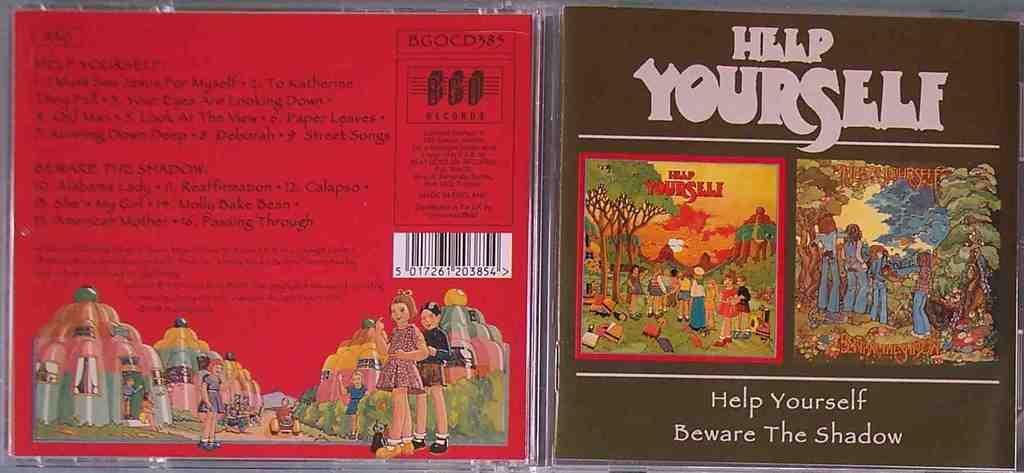Provide a one-sentence caption for the provided image. A CD cover is opened showing both sides for the Help Yourself CD. 